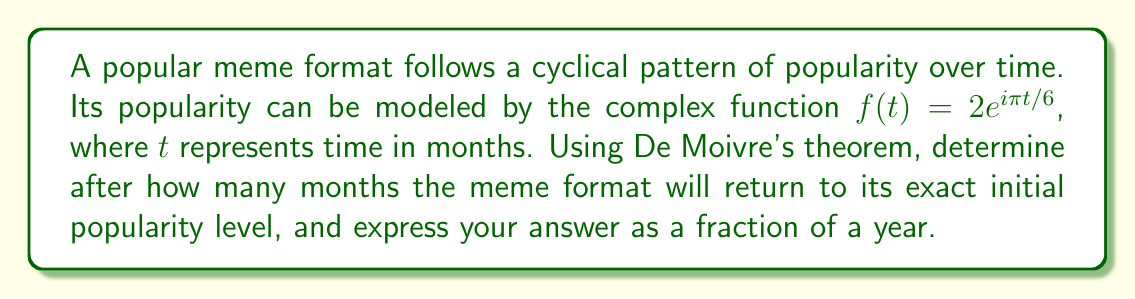Can you solve this math problem? Let's approach this step-by-step:

1) De Moivre's theorem states that for any real number $x$ and integer $n$:

   $$(cos(x) + i\sin(x))^n = cos(nx) + i\sin(nx)$$

2) In our case, $f(t) = 2e^{i\pi t/6} = 2(cos(\pi t/6) + i\sin(\pi t/6))$

3) The meme format will return to its initial popularity when the complex number makes a complete rotation, i.e., when the angle is a multiple of $2\pi$:

   $$\frac{\pi t}{6} = 2\pi n$$, where $n$ is a positive integer

4) Solving for $t$:

   $$t = 12n$$

5) This means the meme format returns to its initial popularity every 12 months.

6) To express this as a fraction of a year:

   $$\frac{12 \text{ months}}{12 \text{ months/year}} = 1 \text{ year}$$

Therefore, the meme format returns to its exact initial popularity level after 1 year.
Answer: $1$ year 